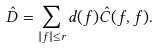Convert formula to latex. <formula><loc_0><loc_0><loc_500><loc_500>\hat { D } = \sum _ { \| f \| \leq r } d ( f ) \hat { C } ( f , f ) .</formula> 